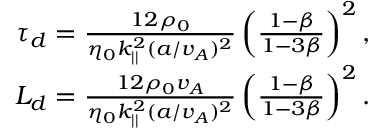<formula> <loc_0><loc_0><loc_500><loc_500>\begin{array} { r } { \tau _ { d } = \frac { 1 2 \rho _ { 0 } } { \eta _ { 0 } k _ { | | } ^ { 2 } ( a / v _ { A } ) ^ { 2 } } \left ( \frac { 1 - \beta } { 1 - 3 \beta } \right ) ^ { 2 } , } \\ { L _ { d } = \frac { 1 2 \rho _ { 0 } v _ { A } } { \eta _ { 0 } k _ { | | } ^ { 2 } ( a / v _ { A } ) ^ { 2 } } \left ( \frac { 1 - \beta } { 1 - 3 \beta } \right ) ^ { 2 } . } \end{array}</formula> 